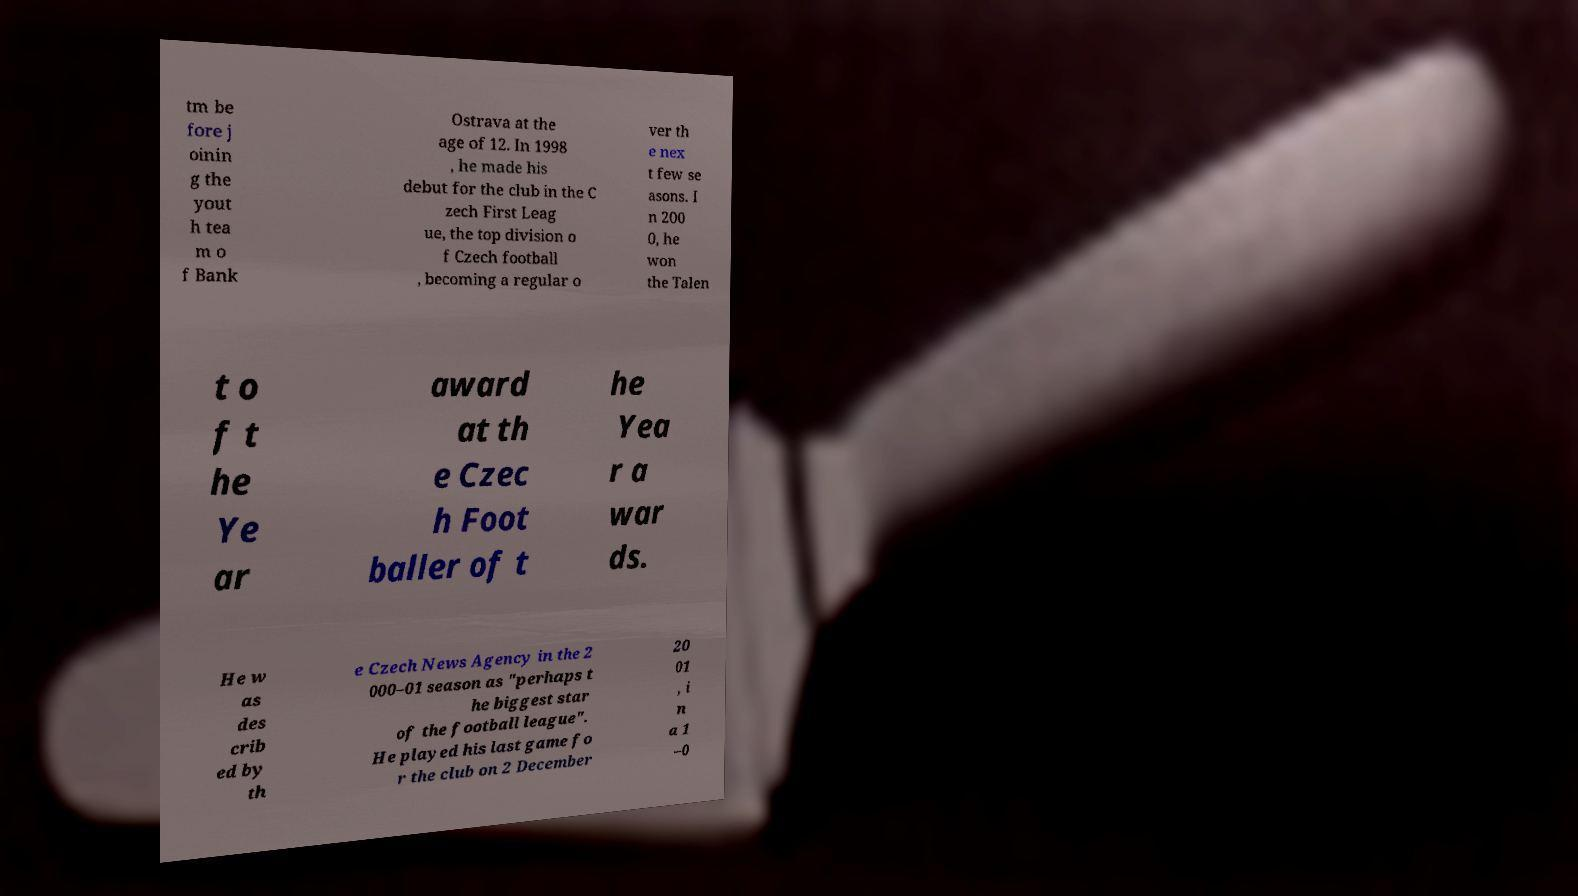Please read and relay the text visible in this image. What does it say? tm be fore j oinin g the yout h tea m o f Bank Ostrava at the age of 12. In 1998 , he made his debut for the club in the C zech First Leag ue, the top division o f Czech football , becoming a regular o ver th e nex t few se asons. I n 200 0, he won the Talen t o f t he Ye ar award at th e Czec h Foot baller of t he Yea r a war ds. He w as des crib ed by th e Czech News Agency in the 2 000–01 season as "perhaps t he biggest star of the football league". He played his last game fo r the club on 2 December 20 01 , i n a 1 –0 